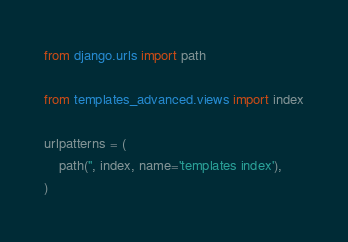<code> <loc_0><loc_0><loc_500><loc_500><_Python_>from django.urls import path

from templates_advanced.views import index

urlpatterns = (
    path('', index, name='templates index'),
)
</code> 